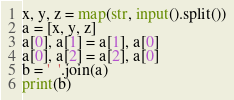<code> <loc_0><loc_0><loc_500><loc_500><_Python_>x, y, z = map(str, input().split())
a = [x, y, z]
a[0], a[1] = a[1], a[0]
a[0], a[2] = a[2], a[0]
b = '  '.join(a)
print(b)</code> 